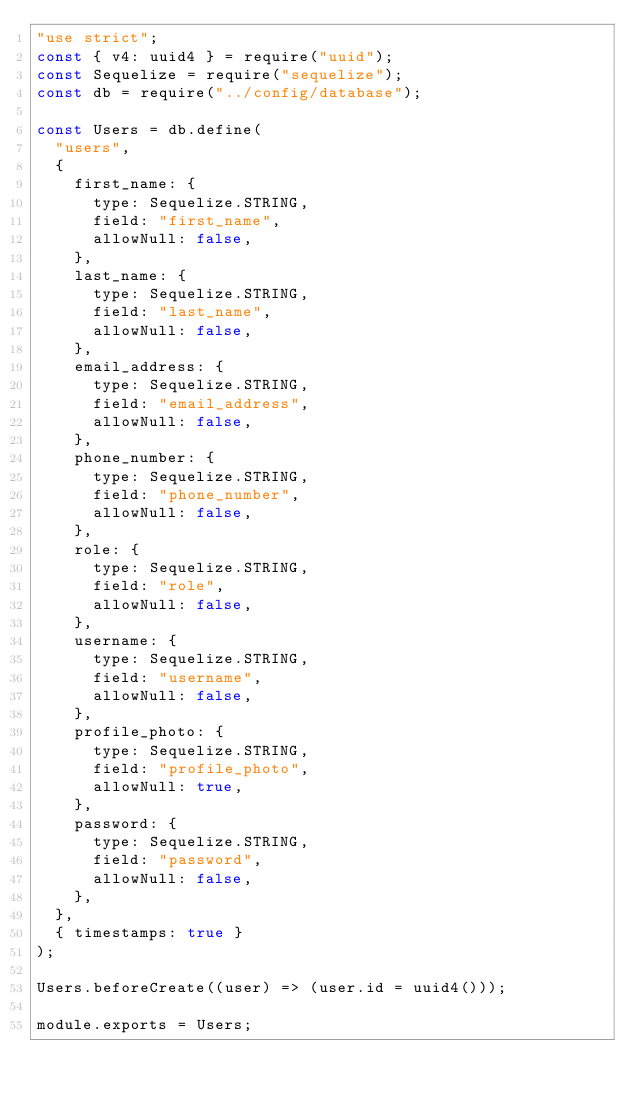<code> <loc_0><loc_0><loc_500><loc_500><_JavaScript_>"use strict";
const { v4: uuid4 } = require("uuid");
const Sequelize = require("sequelize");
const db = require("../config/database");

const Users = db.define(
  "users",
  {
    first_name: {
      type: Sequelize.STRING,
      field: "first_name",
      allowNull: false,
    },
    last_name: {
      type: Sequelize.STRING,
      field: "last_name",
      allowNull: false,
    },
    email_address: {
      type: Sequelize.STRING,
      field: "email_address",
      allowNull: false,
    },
    phone_number: {
      type: Sequelize.STRING,
      field: "phone_number",
      allowNull: false,
    },
    role: {
      type: Sequelize.STRING,
      field: "role",
      allowNull: false,
    },
    username: {
      type: Sequelize.STRING,
      field: "username",
      allowNull: false,
    },
    profile_photo: {
      type: Sequelize.STRING,
      field: "profile_photo",
      allowNull: true,
    },
    password: {
      type: Sequelize.STRING,
      field: "password",
      allowNull: false,
    },
  },
  { timestamps: true }
);

Users.beforeCreate((user) => (user.id = uuid4()));

module.exports = Users;
</code> 